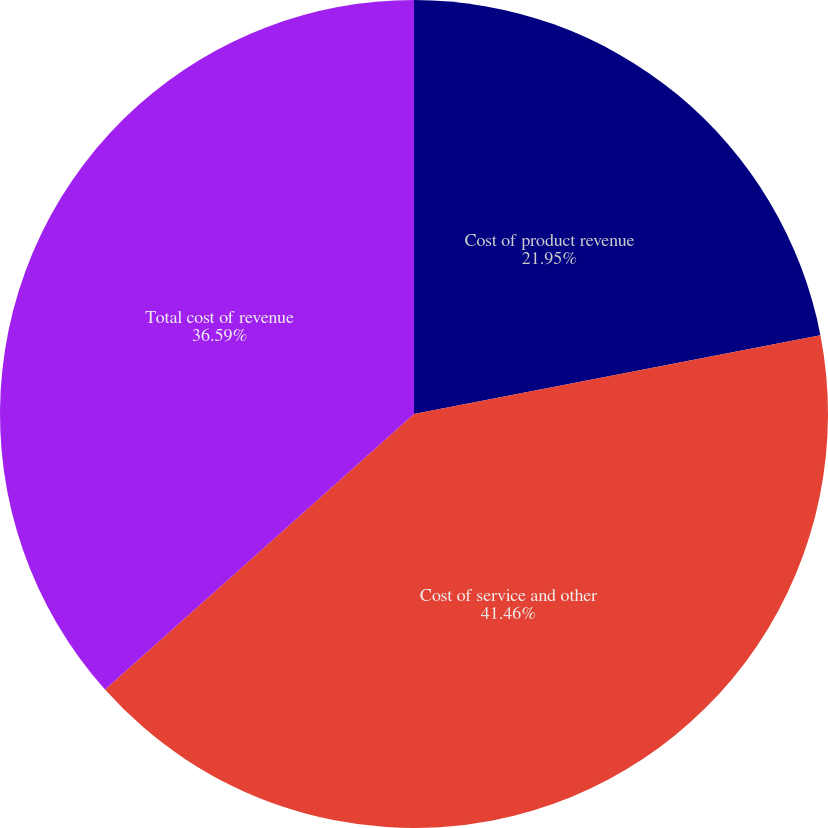Convert chart to OTSL. <chart><loc_0><loc_0><loc_500><loc_500><pie_chart><fcel>Cost of product revenue<fcel>Cost of service and other<fcel>Total cost of revenue<nl><fcel>21.95%<fcel>41.46%<fcel>36.59%<nl></chart> 